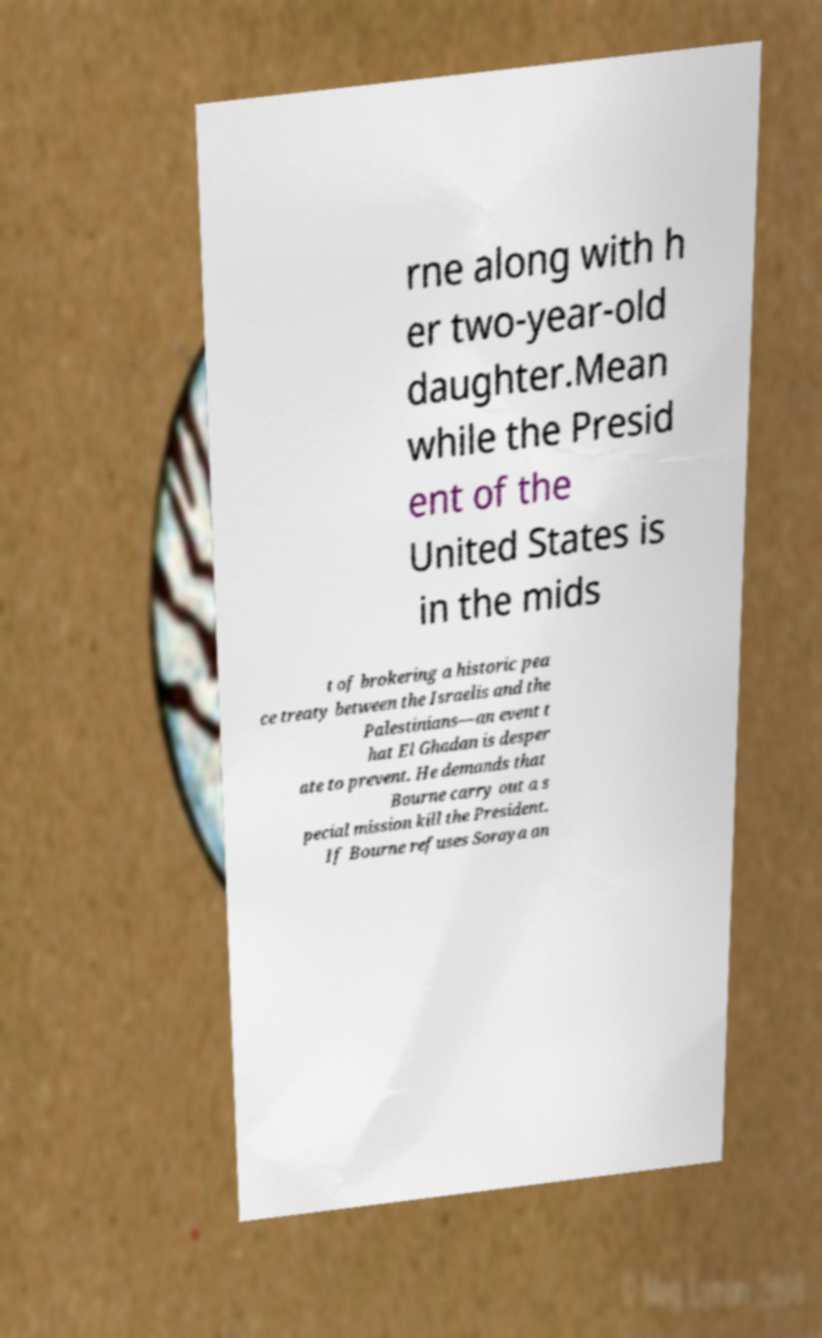There's text embedded in this image that I need extracted. Can you transcribe it verbatim? rne along with h er two-year-old daughter.Mean while the Presid ent of the United States is in the mids t of brokering a historic pea ce treaty between the Israelis and the Palestinians—an event t hat El Ghadan is desper ate to prevent. He demands that Bourne carry out a s pecial mission kill the President. If Bourne refuses Soraya an 